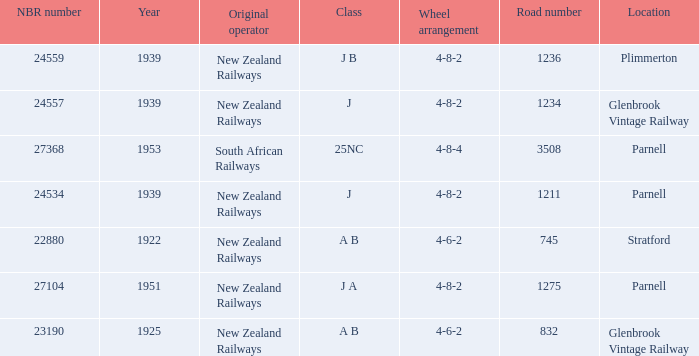What is the highest NBR number that corresponds to the J class and the road number of 1211? 24534.0. 